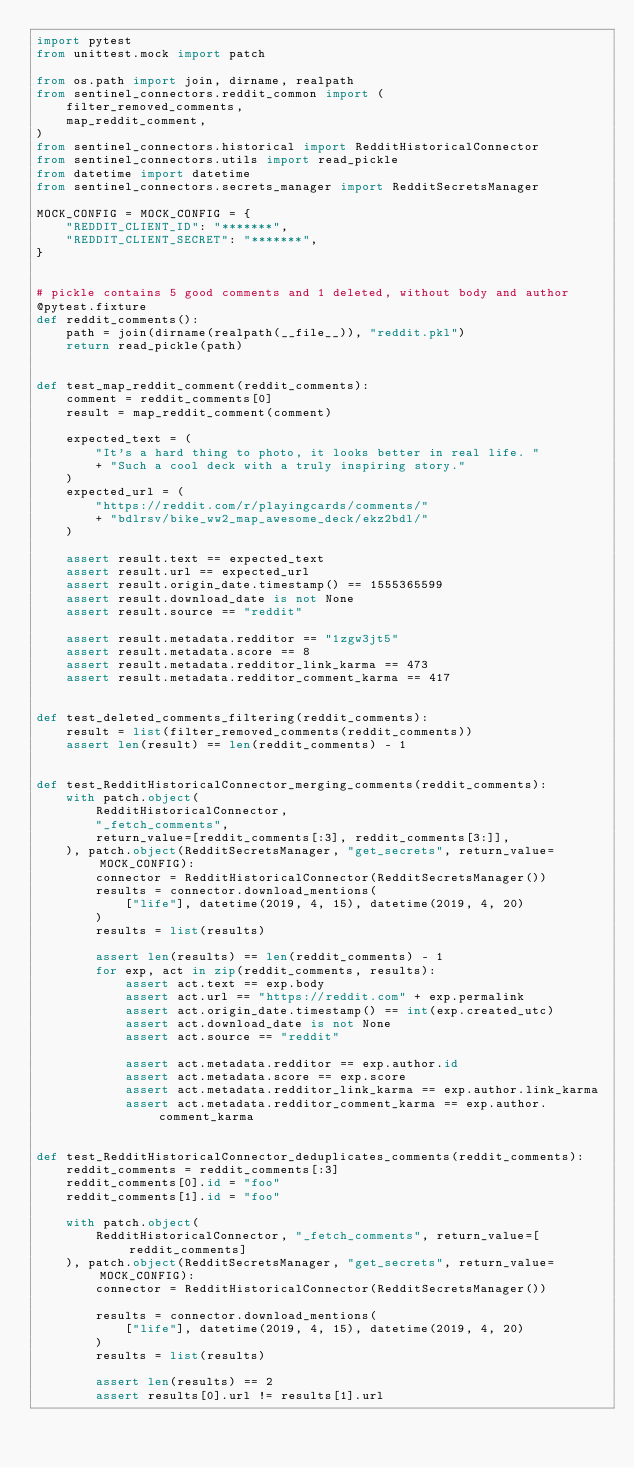Convert code to text. <code><loc_0><loc_0><loc_500><loc_500><_Python_>import pytest
from unittest.mock import patch

from os.path import join, dirname, realpath
from sentinel_connectors.reddit_common import (
    filter_removed_comments,
    map_reddit_comment,
)
from sentinel_connectors.historical import RedditHistoricalConnector
from sentinel_connectors.utils import read_pickle
from datetime import datetime
from sentinel_connectors.secrets_manager import RedditSecretsManager

MOCK_CONFIG = MOCK_CONFIG = {
    "REDDIT_CLIENT_ID": "*******",
    "REDDIT_CLIENT_SECRET": "*******",
}


# pickle contains 5 good comments and 1 deleted, without body and author
@pytest.fixture
def reddit_comments():
    path = join(dirname(realpath(__file__)), "reddit.pkl")
    return read_pickle(path)


def test_map_reddit_comment(reddit_comments):
    comment = reddit_comments[0]
    result = map_reddit_comment(comment)

    expected_text = (
        "It's a hard thing to photo, it looks better in real life. "
        + "Such a cool deck with a truly inspiring story."
    )
    expected_url = (
        "https://reddit.com/r/playingcards/comments/"
        + "bdlrsv/bike_ww2_map_awesome_deck/ekz2bdl/"
    )

    assert result.text == expected_text
    assert result.url == expected_url
    assert result.origin_date.timestamp() == 1555365599
    assert result.download_date is not None
    assert result.source == "reddit"

    assert result.metadata.redditor == "1zgw3jt5"
    assert result.metadata.score == 8
    assert result.metadata.redditor_link_karma == 473
    assert result.metadata.redditor_comment_karma == 417


def test_deleted_comments_filtering(reddit_comments):
    result = list(filter_removed_comments(reddit_comments))
    assert len(result) == len(reddit_comments) - 1


def test_RedditHistoricalConnector_merging_comments(reddit_comments):
    with patch.object(
        RedditHistoricalConnector,
        "_fetch_comments",
        return_value=[reddit_comments[:3], reddit_comments[3:]],
    ), patch.object(RedditSecretsManager, "get_secrets", return_value=MOCK_CONFIG):
        connector = RedditHistoricalConnector(RedditSecretsManager())
        results = connector.download_mentions(
            ["life"], datetime(2019, 4, 15), datetime(2019, 4, 20)
        )
        results = list(results)

        assert len(results) == len(reddit_comments) - 1
        for exp, act in zip(reddit_comments, results):
            assert act.text == exp.body
            assert act.url == "https://reddit.com" + exp.permalink
            assert act.origin_date.timestamp() == int(exp.created_utc)
            assert act.download_date is not None
            assert act.source == "reddit"

            assert act.metadata.redditor == exp.author.id
            assert act.metadata.score == exp.score
            assert act.metadata.redditor_link_karma == exp.author.link_karma
            assert act.metadata.redditor_comment_karma == exp.author.comment_karma


def test_RedditHistoricalConnector_deduplicates_comments(reddit_comments):
    reddit_comments = reddit_comments[:3]
    reddit_comments[0].id = "foo"
    reddit_comments[1].id = "foo"

    with patch.object(
        RedditHistoricalConnector, "_fetch_comments", return_value=[reddit_comments]
    ), patch.object(RedditSecretsManager, "get_secrets", return_value=MOCK_CONFIG):
        connector = RedditHistoricalConnector(RedditSecretsManager())

        results = connector.download_mentions(
            ["life"], datetime(2019, 4, 15), datetime(2019, 4, 20)
        )
        results = list(results)

        assert len(results) == 2
        assert results[0].url != results[1].url
</code> 